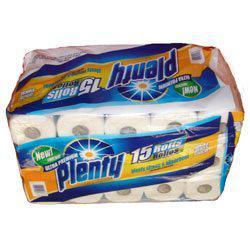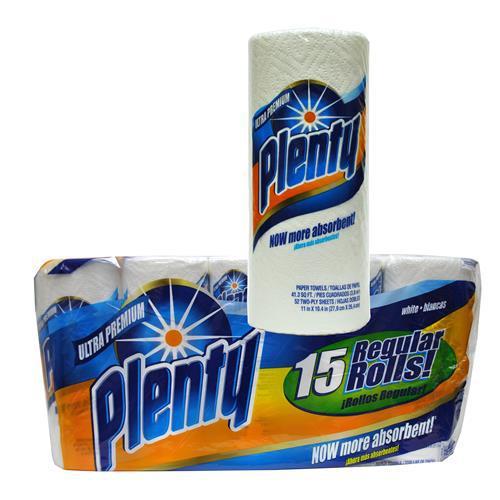The first image is the image on the left, the second image is the image on the right. Examine the images to the left and right. Is the description "There are two packages of paper towels and one single paper towel roll." accurate? Answer yes or no. Yes. The first image is the image on the left, the second image is the image on the right. Analyze the images presented: Is the assertion "There are exactly 31 rolls of paper towels." valid? Answer yes or no. Yes. 